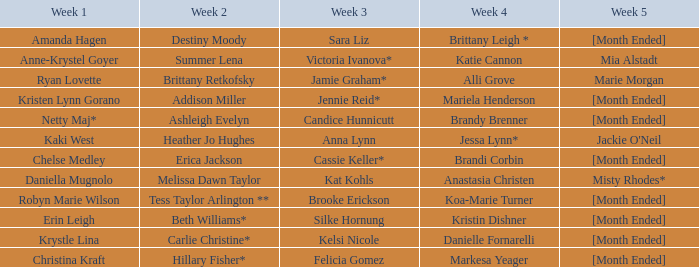What is the week 1 with candice hunnicutt in week 3? Netty Maj*. Can you give me this table as a dict? {'header': ['Week 1', 'Week 2', 'Week 3', 'Week 4', 'Week 5'], 'rows': [['Amanda Hagen', 'Destiny Moody', 'Sara Liz', 'Brittany Leigh *', '[Month Ended]'], ['Anne-Krystel Goyer', 'Summer Lena', 'Victoria Ivanova*', 'Katie Cannon', 'Mia Alstadt'], ['Ryan Lovette', 'Brittany Retkofsky', 'Jamie Graham*', 'Alli Grove', 'Marie Morgan'], ['Kristen Lynn Gorano', 'Addison Miller', 'Jennie Reid*', 'Mariela Henderson', '[Month Ended]'], ['Netty Maj*', 'Ashleigh Evelyn', 'Candice Hunnicutt', 'Brandy Brenner', '[Month Ended]'], ['Kaki West', 'Heather Jo Hughes', 'Anna Lynn', 'Jessa Lynn*', "Jackie O'Neil"], ['Chelse Medley', 'Erica Jackson', 'Cassie Keller*', 'Brandi Corbin', '[Month Ended]'], ['Daniella Mugnolo', 'Melissa Dawn Taylor', 'Kat Kohls', 'Anastasia Christen', 'Misty Rhodes*'], ['Robyn Marie Wilson', 'Tess Taylor Arlington **', 'Brooke Erickson', 'Koa-Marie Turner', '[Month Ended]'], ['Erin Leigh', 'Beth Williams*', 'Silke Hornung', 'Kristin Dishner', '[Month Ended]'], ['Krystle Lina', 'Carlie Christine*', 'Kelsi Nicole', 'Danielle Fornarelli', '[Month Ended]'], ['Christina Kraft', 'Hillary Fisher*', 'Felicia Gomez', 'Markesa Yeager', '[Month Ended]']]} 